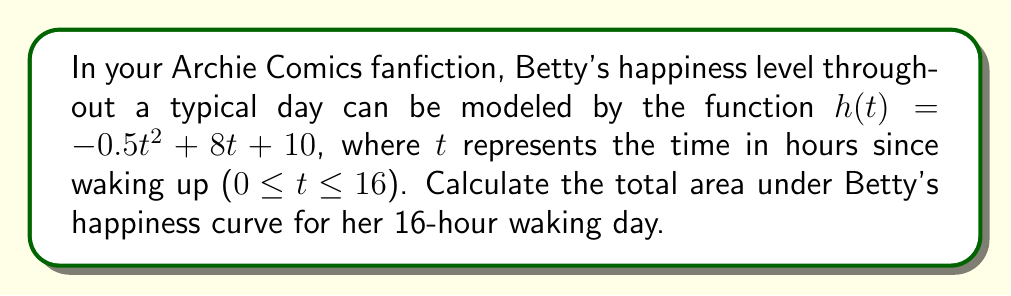Could you help me with this problem? To find the area under the curve, we need to integrate the function $h(t)$ from $t=0$ to $t=16$. Here's how we can solve this problem:

1) The integral we need to evaluate is:

   $$\int_0^{16} (-0.5t^2 + 8t + 10) \, dt$$

2) Let's integrate each term separately:

   $$\int -0.5t^2 \, dt = -\frac{1}{6}t^3 + C$$
   $$\int 8t \, dt = 4t^2 + C$$
   $$\int 10 \, dt = 10t + C$$

3) Combining these, we get:

   $$\int (-0.5t^2 + 8t + 10) \, dt = -\frac{1}{6}t^3 + 4t^2 + 10t + C$$

4) Now, we apply the fundamental theorem of calculus:

   $$\left[-\frac{1}{6}t^3 + 4t^2 + 10t\right]_0^{16}$$

5) Evaluate at $t=16$ and $t=0$:

   $$\left(-\frac{1}{6}(16)^3 + 4(16)^2 + 10(16)\right) - \left(-\frac{1}{6}(0)^3 + 4(0)^2 + 10(0)\right)$$

6) Simplify:

   $$\left(-682.67 + 1024 + 160\right) - (0)$$
   $$= 501.33$$

Therefore, the total area under Betty's happiness curve for her 16-hour waking day is approximately 501.33 happiness-hours.
Answer: 501.33 happiness-hours 